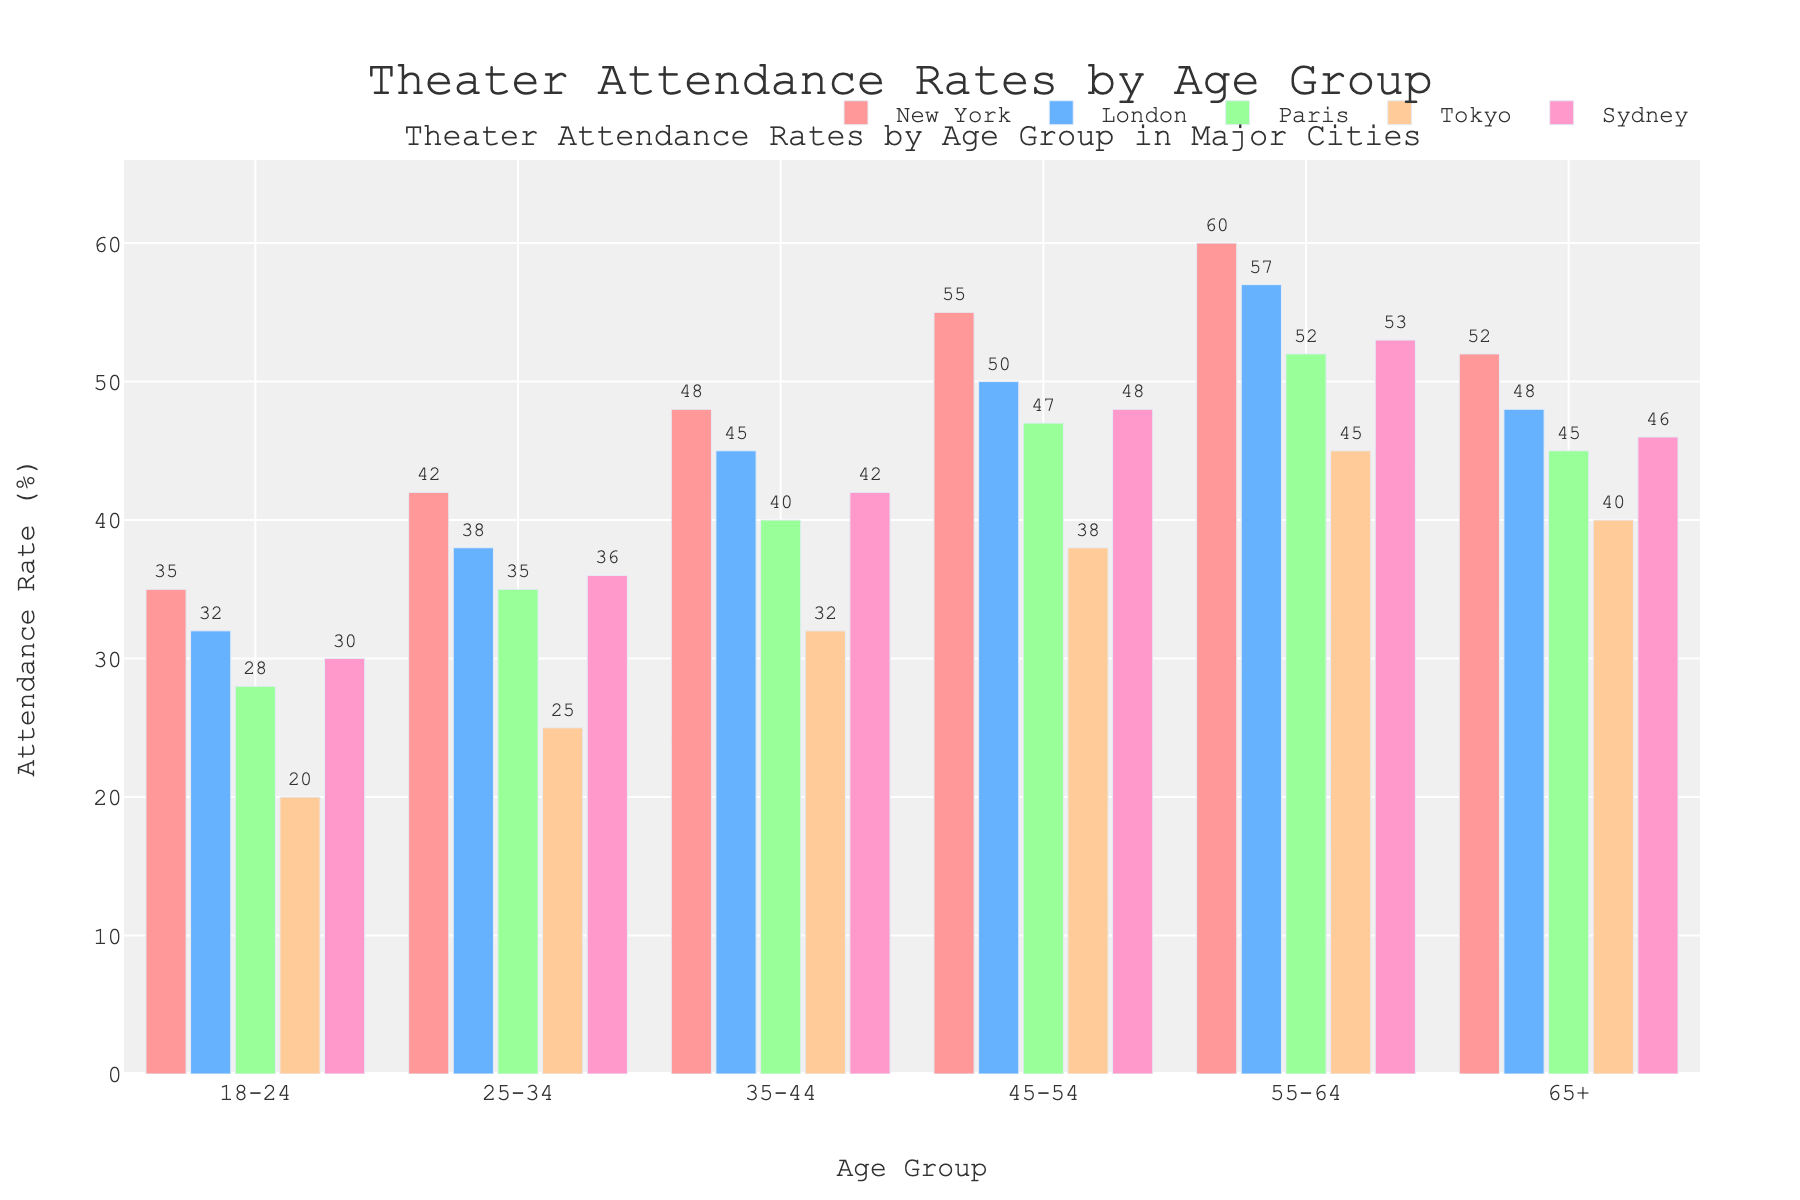What is the attendance rate for the 18-24 age group in New York? The attendance rate for the 18-24 age group can be found directly from the bar labeled "18-24" under the New York column, which is 35%.
Answer: 35% Which city has the highest theater attendance rate for the 55-64 age group? To find the city with the highest attendance rate for the 55-64 age group, we compare the heights of the bars for this age group across all the cities. The highest bar is in New York with a rate of 60%.
Answer: New York How much higher is the attendance rate for the 45-54 age group in Tokyo compared to the 25-34 age group in Sydney? The attendance rate for the 45-54 age group in Tokyo is 38%, and for the 25-34 age group in Sydney, it is 36%. The difference is calculated as 38% - 36% = 2%.
Answer: 2% Which age group has the lowest attendance rate in Paris, and what is that rate? We need to look at the bar heights for each age group in the Paris column. The lowest attendance rate is for the 18-24 age group, which is 28%.
Answer: 18-24, 28% What is the average attendance rate across all cities for the 35-44 age group? The attendance rates for the 35-44 age group are New York: 48%, London: 45%, Paris: 40%, Tokyo: 32%, and Sydney: 42%. The average is calculated as (48 + 45 + 40 + 32 + 42) / 5 = 207 / 5 = 41.4%.
Answer: 41.4% By how much does the theater attendance rate for the 65+ age group in London exceed the rate in Tokyo? The attendance rate for the 65+ age group in London is 48%, and in Tokyo, it is 40%. The difference is 48% - 40% = 8%.
Answer: 8% Between the cities of London and Paris, which one has a higher attendance rate overall for all age groups? We sum up the attendance rates for all age groups for both cities: London (32+38+45+50+57+48) = 270%; Paris (28+35+40+47+52+45) = 247%. London has a higher total attendance rate overall.
Answer: London For the 25-34 age group, which city shows the highest attendance rate, and what is that rate? For the 25-34 age group, the attendance rates are New York: 42%, London: 38%, Paris: 35%, Tokyo: 25%, and Sydney: 36%. The highest rate is in New York, which is 42%.
Answer: New York, 42% What is the combined attendance rate for the 18-24 and 55-64 age groups in Sydney? In Sydney, the attendance rates for the 18-24 and 55-64 age groups are 30% and 53%, respectively. The combined rate is 30% + 53% = 83%.
Answer: 83% 